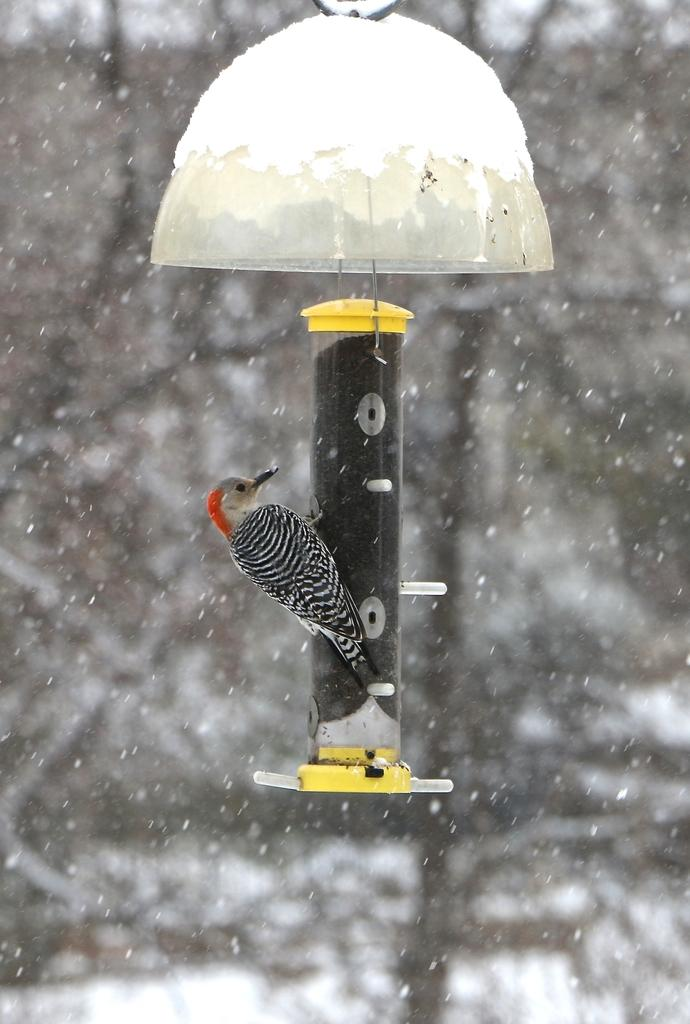What is the main object in the image? There is a bird feeder in the image. Is there any bird on the bird feeder? Yes, there is a bird on the bird feeder. What can be seen in the background of the image? Snow is falling in the background of the image. How would you describe the clarity of the background? The background is blurry. What type of loaf is being baked in the image? There is no loaf or baking activity present in the image; it features a bird feeder with a bird and falling snow in the background. 